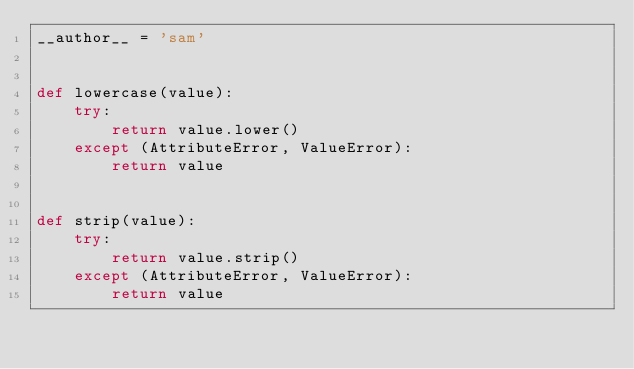<code> <loc_0><loc_0><loc_500><loc_500><_Python_>__author__ = 'sam'


def lowercase(value):
    try:
        return value.lower()
    except (AttributeError, ValueError):
        return value


def strip(value):
    try:
        return value.strip()
    except (AttributeError, ValueError):
        return value


</code> 